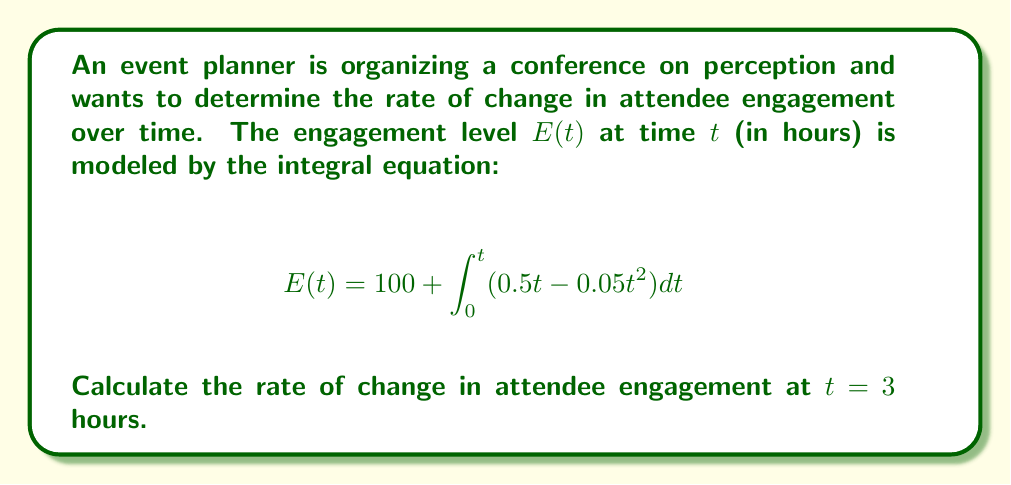Could you help me with this problem? To solve this problem, we need to follow these steps:

1) First, we need to find $E(t)$ by solving the integral equation:

   $$E(t) = 100 + \int_0^t (0.5t - 0.05t^2) dt$$

2) Integrate the function inside the integral:

   $$E(t) = 100 + [\frac{0.5t^2}{2} - \frac{0.05t^3}{3}]_0^t$$

3) Evaluate the integral:

   $$E(t) = 100 + (\frac{0.25t^2}{1} - \frac{0.05t^3}{3}) - (0)$$

   $$E(t) = 100 + 0.25t^2 - \frac{0.05t^3}{3}$$

4) Now that we have $E(t)$, to find the rate of change, we need to differentiate $E(t)$ with respect to $t$:

   $$\frac{dE}{dt} = 0.5t - 0.05t^2$$

5) To find the rate of change at $t = 3$, we substitute $t = 3$ into this equation:

   $$\frac{dE}{dt}\bigg|_{t=3} = 0.5(3) - 0.05(3)^2$$

   $$\frac{dE}{dt}\bigg|_{t=3} = 1.5 - 0.45 = 1.05$$

Therefore, the rate of change in attendee engagement at $t = 3$ hours is 1.05 units per hour.
Answer: 1.05 units/hour 